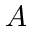Convert formula to latex. <formula><loc_0><loc_0><loc_500><loc_500>A</formula> 